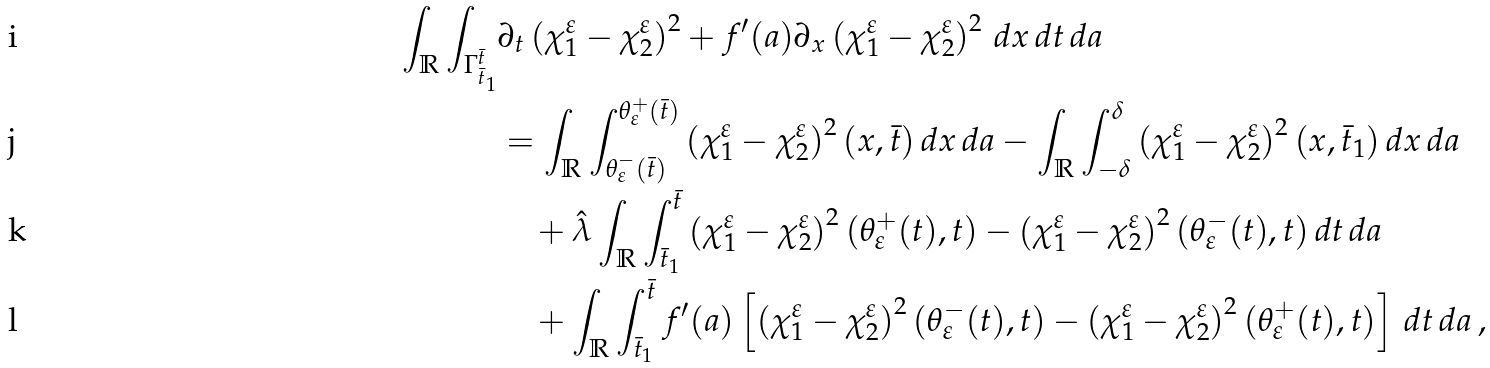Convert formula to latex. <formula><loc_0><loc_0><loc_500><loc_500>\int _ { \mathbb { R } } \int _ { \Gamma _ { \bar { t } _ { 1 } } ^ { \bar { t } } } & \partial _ { t } \left ( \chi _ { 1 } ^ { \varepsilon } - \chi _ { 2 } ^ { \varepsilon } \right ) ^ { 2 } + f ^ { \prime } ( a ) \partial _ { x } \left ( \chi _ { 1 } ^ { \varepsilon } - \chi _ { 2 } ^ { \varepsilon } \right ) ^ { 2 } \, d x \, d t \, d a \\ & = \int _ { \mathbb { R } } \int _ { \theta ^ { - } _ { \varepsilon } ( \bar { t } ) } ^ { \theta _ { \varepsilon } ^ { + } ( \bar { t } ) } \left ( \chi _ { 1 } ^ { \varepsilon } - \chi _ { 2 } ^ { \varepsilon } \right ) ^ { 2 } ( x , \bar { t } ) \, d x \, d a - \int _ { \mathbb { R } } \int _ { - \delta } ^ { \delta } \left ( \chi _ { 1 } ^ { \varepsilon } - \chi _ { 2 } ^ { \varepsilon } \right ) ^ { 2 } ( x , \bar { t } _ { 1 } ) \, d x \, d a \\ & \quad + \hat { \lambda } \int _ { \mathbb { R } } \int _ { \bar { t } _ { 1 } } ^ { \bar { t } } \left ( \chi _ { 1 } ^ { \varepsilon } - \chi _ { 2 } ^ { \varepsilon } \right ) ^ { 2 } ( \theta ^ { + } _ { \varepsilon } ( t ) , t ) - \left ( \chi _ { 1 } ^ { \varepsilon } - \chi _ { 2 } ^ { \varepsilon } \right ) ^ { 2 } ( \theta _ { \varepsilon } ^ { - } ( t ) , t ) \, d t \, d a \\ & \quad + \int _ { \mathbb { R } } \int _ { \bar { t } _ { 1 } } ^ { \bar { t } } f ^ { \prime } ( a ) \left [ \left ( \chi _ { 1 } ^ { \varepsilon } - \chi _ { 2 } ^ { \varepsilon } \right ) ^ { 2 } ( \theta _ { \varepsilon } ^ { - } ( t ) , t ) - \left ( \chi _ { 1 } ^ { \varepsilon } - \chi _ { 2 } ^ { \varepsilon } \right ) ^ { 2 } ( \theta _ { \varepsilon } ^ { + } ( t ) , t ) \right ] \, d t \, d a \, ,</formula> 